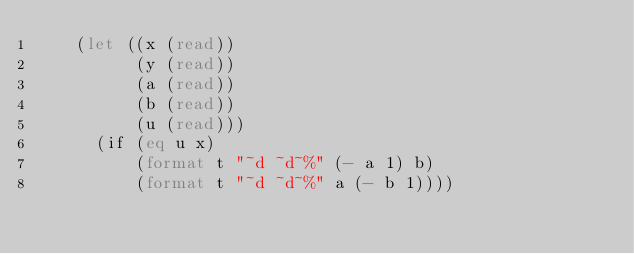<code> <loc_0><loc_0><loc_500><loc_500><_Lisp_>    (let ((x (read)) 
          (y (read))
          (a (read))
          (b (read))
          (u (read)))
      (if (eq u x)
          (format t "~d ~d~%" (- a 1) b)
          (format t "~d ~d~%" a (- b 1))))</code> 